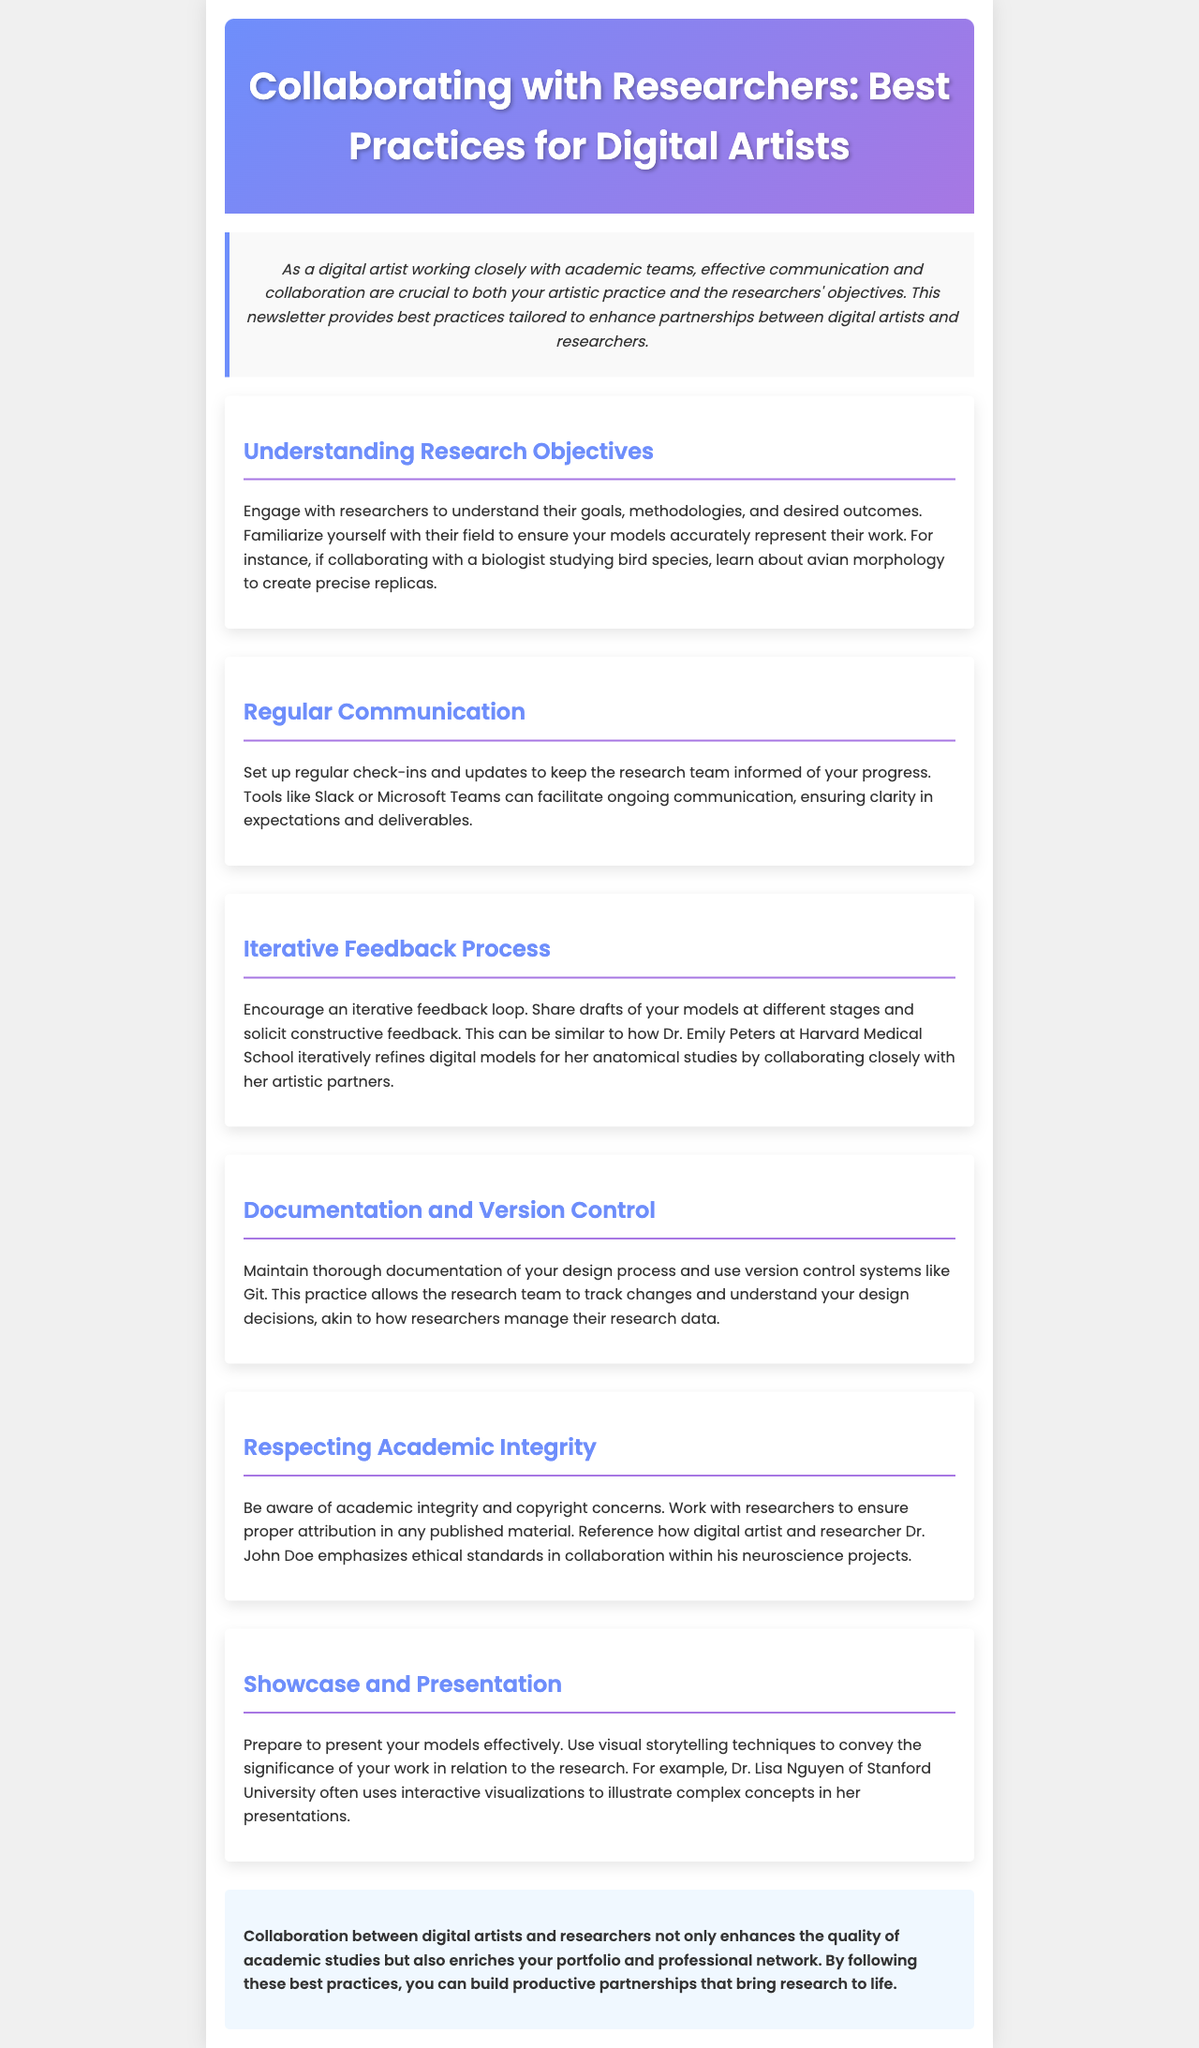What are the best practices for digital artists? The document lists several best practices tailored to enhance partnerships between digital artists and researchers.
Answer: Best Practices for Digital Artists Who is mentioned as collaborating closely with her artistic partners? Dr. Emily Peters at Harvard Medical School is noted for her iterative refinement of digital models for anatomical studies.
Answer: Dr. Emily Peters What is one tool suggested for regular communication? The document suggests using tools like Slack or Microsoft Teams for ongoing communication with the research team.
Answer: Slack or Microsoft Teams What practice allows the research team to track changes in the design? Maintaining thorough documentation of the design process is important for allowing the research team to track changes.
Answer: Documentation Which academic integrity aspect must be respected during collaboration? The document emphasizes the importance of ensuring proper attribution in any published material.
Answer: Proper attribution What visual technique is recommended for showcasing models? Using visual storytelling techniques is recommended to convey the significance of the work in relation to research.
Answer: Visual storytelling techniques What should digital artists prepare for effectively? Digital artists should prepare to present their models effectively.
Answer: Present Who often uses interactive visualizations in her presentations? Dr. Lisa Nguyen of Stanford University is noted for using interactive visualizations to illustrate complex concepts.
Answer: Dr. Lisa Nguyen What is encouraged to enhance collaboration between digital artists and researchers? Following the best practices listed enhances the collaboration quality between the two parties.
Answer: Best practices 